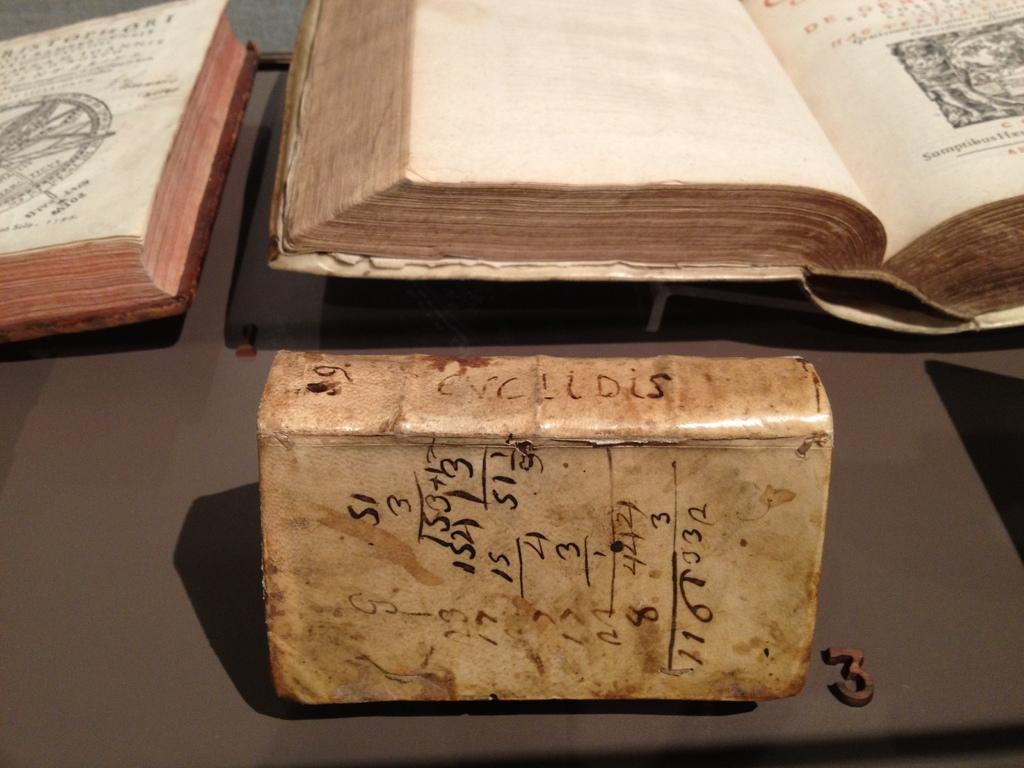Provide a one-sentence caption for the provided image. A very old leather bound book with the letters "Enclidis" on the spine. 